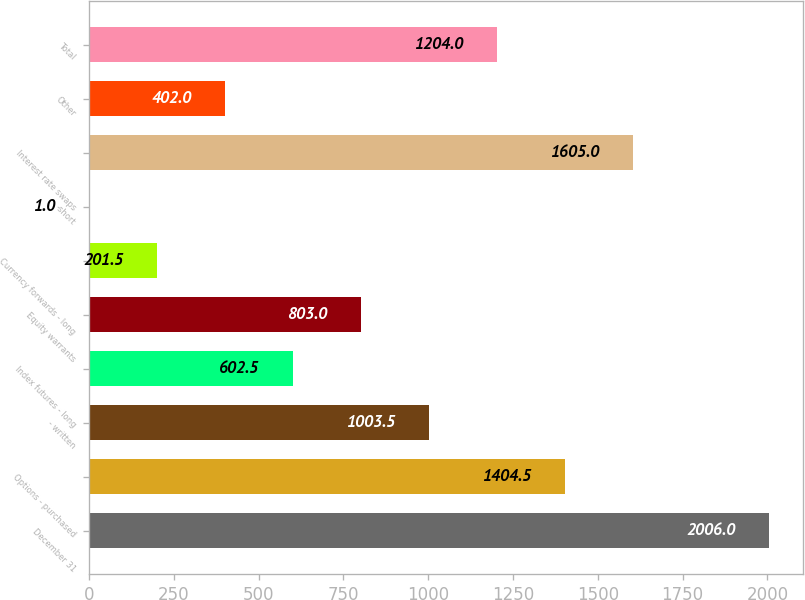<chart> <loc_0><loc_0><loc_500><loc_500><bar_chart><fcel>December 31<fcel>Options - purchased<fcel>- written<fcel>Index futures - long<fcel>Equity warrants<fcel>Currency forwards - long<fcel>-short<fcel>Interest rate swaps<fcel>Other<fcel>Total<nl><fcel>2006<fcel>1404.5<fcel>1003.5<fcel>602.5<fcel>803<fcel>201.5<fcel>1<fcel>1605<fcel>402<fcel>1204<nl></chart> 